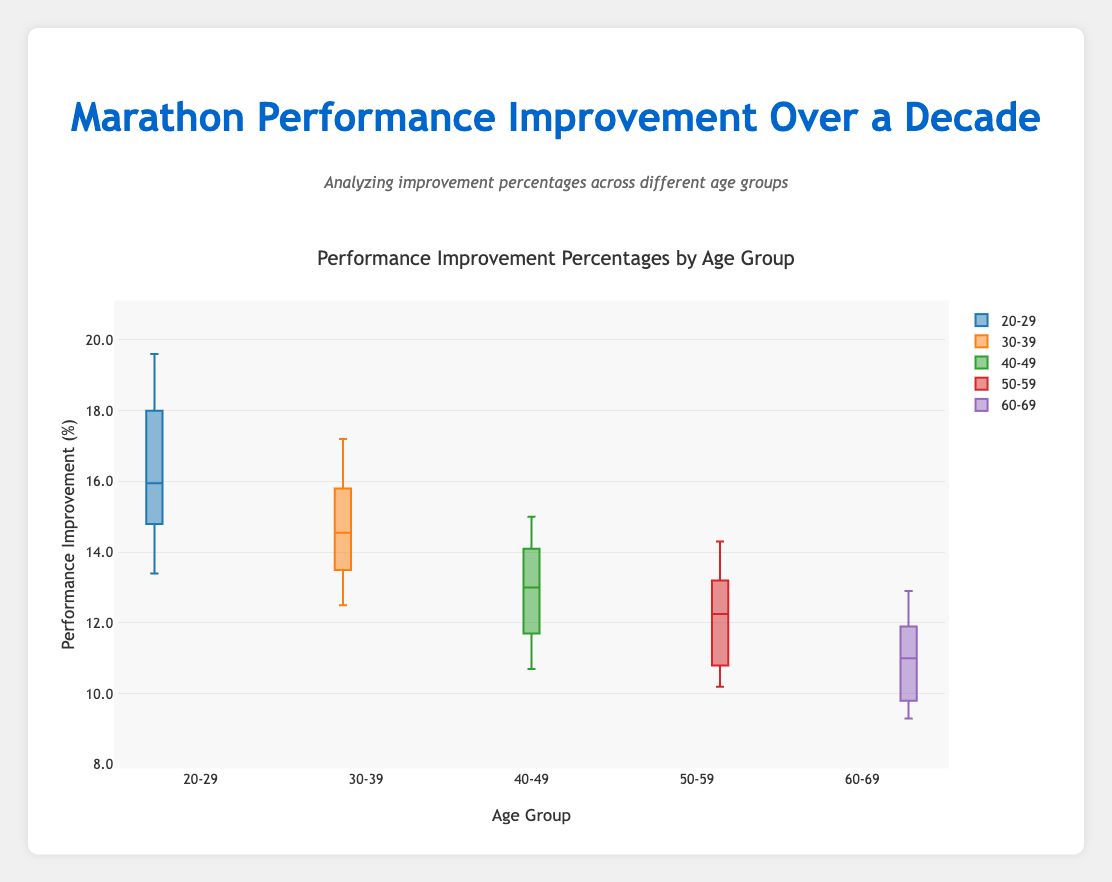What are the age groups shown in the plot? The age groups are represented on the x-axis of the box plot. These include 20-29, 30-39, 40-49, 50-59, and 60-69.
Answer: 20-29, 30-39, 40-49, 50-59, 60-69 What is the title of the plot? The title of the plot is present at the top of the figure. It reads "Performance Improvement Percentages by Age Group".
Answer: Performance Improvement Percentages by Age Group In which age group is the median performance improvement percentage the highest? The median is the middle line in each box of the box plot. The 20-29 age group has the highest median performance improvement percentage.
Answer: 20-29 How does the interquartile range (IQR) for the 20-29 age group compare to the 50-59 age group? The IQR is the range covered by the box, representing the middle 50% of the data. The 20-29 age group has a larger IQR compared to the 50-59 age group, indicating more variability in the performance improvements among the younger runners.
Answer: 20-29 has a larger IQR Which age group has the lowest maximum performance improvement percentage? The *whiskers* of the box plot indicate the range excluding outliers. The 60-69 age group has the lowest maximum performance improvement percentage.
Answer: 60-69 Compare the 25th percentile (lower quartile) for the 30-39 age group to the 40-49 age group. The 25th percentile is the lower edge of the box in the box plot. The 25th percentile for the 30-39 age group is higher than that of the 40-49 age group.
Answer: 30-39 higher than 40-49 Is there any age group where the lower whisker is below 10%? The lower whisker of the box plot goes down to the minimum value excluding outliers. The 50-59 and 60-69 age groups have lower whiskers that are below 10%.
Answer: 50-59, 60-69 How does the mean performance improvement percentage of the 20-29 group compare to the 60-69 group? Although the means are not explicitly displayed, the median, box range, and whiskers give us an indication. The 20-29 age group shows generally higher performance improvement percentages, inferred from its position in the plot.
Answer: 20-29 higher than 60-69 What is the third quartile (75th percentile) for the 40-49 age group? The third quartile is the upper edge of the box in the box plot. For the 40-49 age group, this value is around 14.5%.
Answer: Around 14.5% 